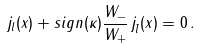<formula> <loc_0><loc_0><loc_500><loc_500>j _ { l } ( x ) + s i g n ( \kappa ) \frac { W _ { - } } { W _ { + } } \, j _ { \bar { l } } ( x ) = 0 \, .</formula> 